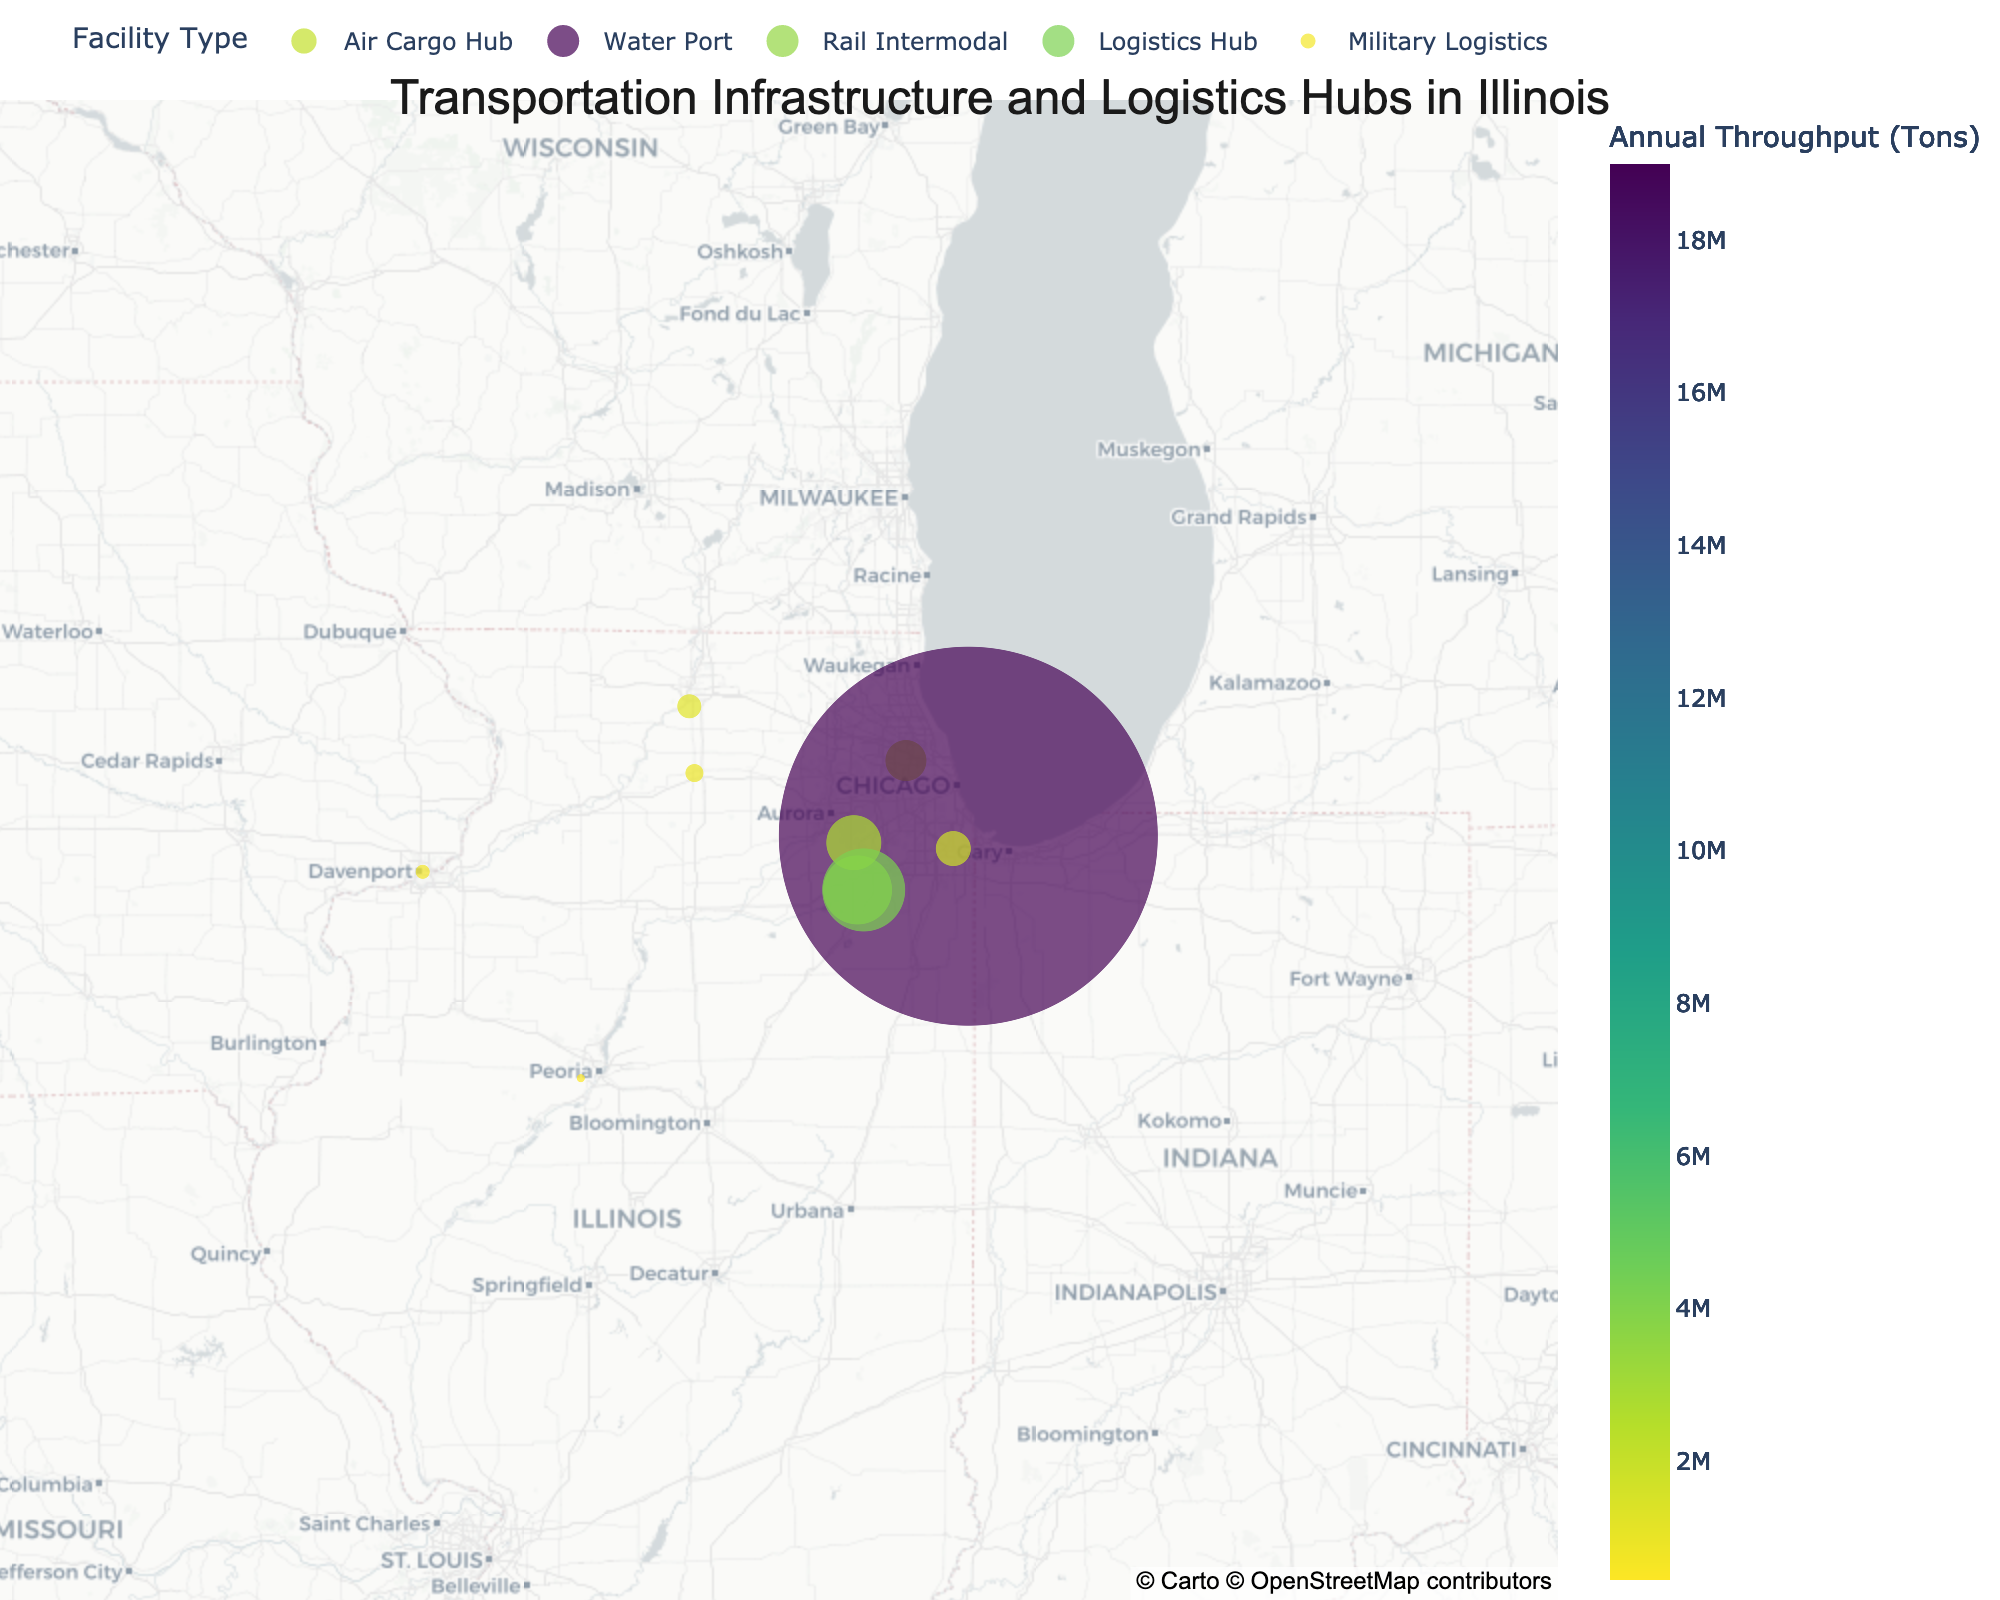How many different types of facilities are depicted in the plot? The legend on the plot shows each facility type as a category. By counting the unique categories listed in the legend, we can determine the number of different types of facilities.
Answer: 5 Which facility has the highest annual throughput in tons? By examining the size and color of the markers, we can identify that the Illinois International Port District has the largest marker and the most intense color, indicating it has the highest throughput.
Answer: Illinois International Port District Which facility among the 'Rail Intermodal' has the lowest annual throughput? To find the 'Rail Intermodal' facilities, look at those labeled in the figure. Compare the marker sizes and color intensity. The Rochelle Railroad Park has the smallest marker and least intense color for 'Rail Intermodal'.
Answer: Rochelle Railroad Park What is the total annual throughput in tons for all 'Air Cargo Hub' facilities combined? Locate the 'Air Cargo Hub' markers in the legend and sum their annual throughput values. Chicago O'Hare International Airport (2,100,000 tons) + UPS Rockford Air Hub (1,250,000 tons) + Peoria International Airport (450,000 tons) equals 3,800,000 tons.
Answer: 3,800,000 tons Which facility is located closest to the geographical center of the map? Find the marker closest to the center point of the map, which is adjusted to center on the average coordinates of all data points. CenterPoint Intermodal Center - Joliet appears to be the closest to this center point.
Answer: CenterPoint Intermodal Center - Joliet Among the logistics hubs, which two facilities are geographically the closest to each other? Look at the 'Logistics Hub' markers and visually compare distances between them. CenterPoint Intermodal Center - Joliet and BNSF Logistics Park Chicago are geographically closest to each other, both located around Joliet, Illinois.
Answer: CenterPoint Intermodal Center - Joliet and BNSF Logistics Park Chicago What is the mean annual throughput in tons of all facilities combined? Calculate the total throughput by summing throughputs of all facilities and then divide by the number of facilities. The total is 33,400,000 tons. There are 10 facilities, so mean throughput is 33,400,000/10.
Answer: 3,340,000 tons Which facility type has the largest range in annual throughput? Calculate the difference between the maximum and minimum annual throughput within each facility type. Compare these ranges. 'Rail Intermodal' ranges from Rochelle Railroad Park (950,000 tons) to BNSF Logistics Park Chicago (3,500,000 tons), a 2,550,000 ton range, which is the largest.
Answer: Rail Intermodal Is there any facility type exclusively located south of Chicago? Consider the latitude values and check if all types are represented. Water Port (Illinois International Port District) is the only type exclusively south of Chicago.
Answer: Water Port 